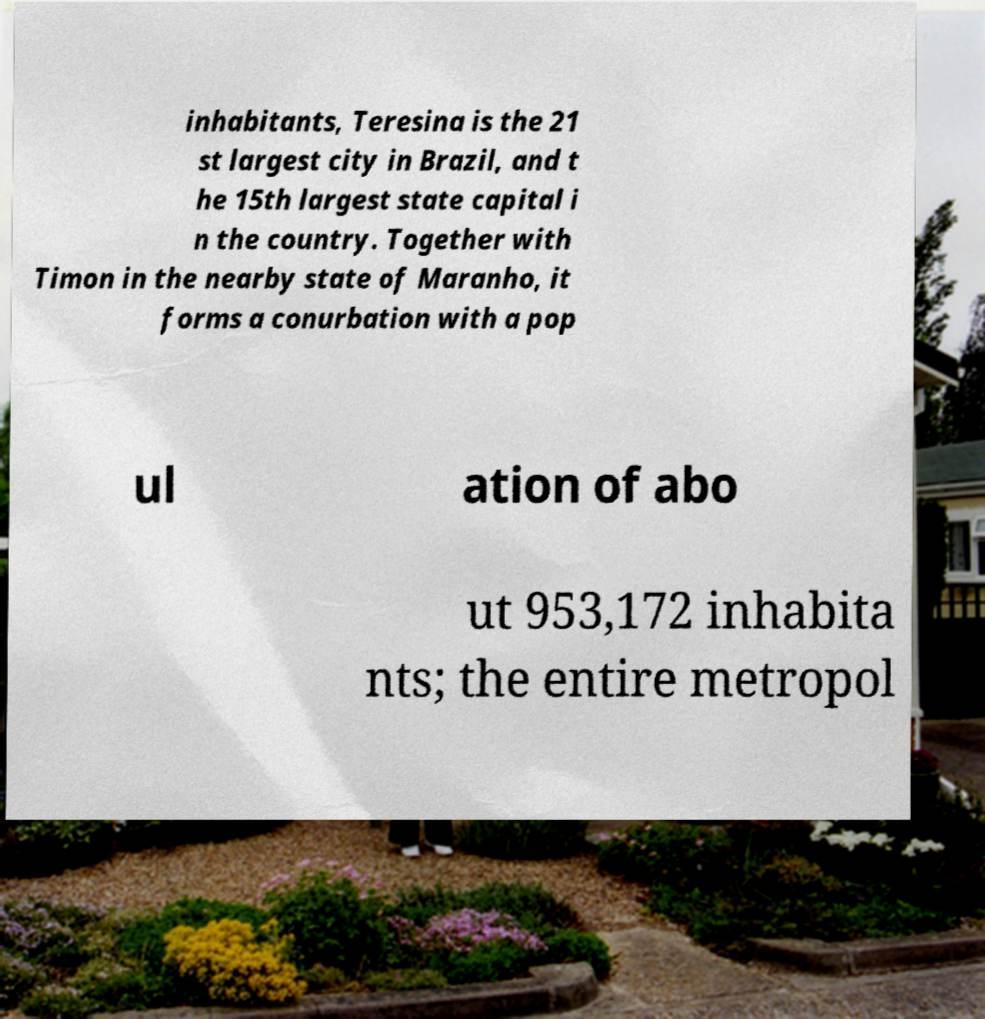For documentation purposes, I need the text within this image transcribed. Could you provide that? inhabitants, Teresina is the 21 st largest city in Brazil, and t he 15th largest state capital i n the country. Together with Timon in the nearby state of Maranho, it forms a conurbation with a pop ul ation of abo ut 953,172 inhabita nts; the entire metropol 